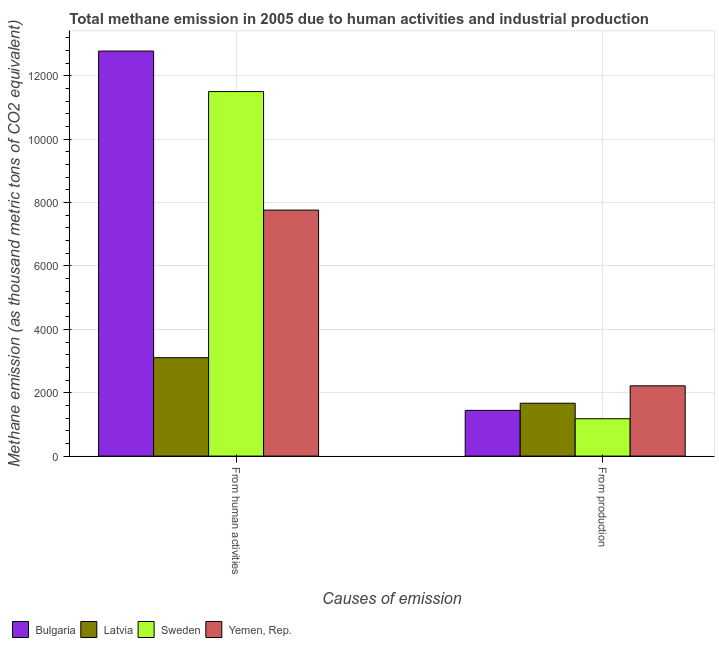How many different coloured bars are there?
Provide a succinct answer. 4. How many groups of bars are there?
Provide a short and direct response. 2. Are the number of bars per tick equal to the number of legend labels?
Provide a short and direct response. Yes. How many bars are there on the 1st tick from the left?
Your answer should be very brief. 4. How many bars are there on the 2nd tick from the right?
Your answer should be very brief. 4. What is the label of the 2nd group of bars from the left?
Keep it short and to the point. From production. What is the amount of emissions from human activities in Yemen, Rep.?
Keep it short and to the point. 7761.1. Across all countries, what is the maximum amount of emissions from human activities?
Provide a short and direct response. 1.28e+04. Across all countries, what is the minimum amount of emissions from human activities?
Provide a succinct answer. 3105. In which country was the amount of emissions generated from industries maximum?
Keep it short and to the point. Yemen, Rep. In which country was the amount of emissions from human activities minimum?
Your response must be concise. Latvia. What is the total amount of emissions from human activities in the graph?
Ensure brevity in your answer.  3.51e+04. What is the difference between the amount of emissions from human activities in Yemen, Rep. and that in Sweden?
Make the answer very short. -3739.8. What is the difference between the amount of emissions generated from industries in Yemen, Rep. and the amount of emissions from human activities in Sweden?
Your answer should be compact. -9284. What is the average amount of emissions generated from industries per country?
Your answer should be compact. 1626.85. What is the difference between the amount of emissions generated from industries and amount of emissions from human activities in Bulgaria?
Keep it short and to the point. -1.13e+04. In how many countries, is the amount of emissions from human activities greater than 9600 thousand metric tons?
Make the answer very short. 2. What is the ratio of the amount of emissions generated from industries in Latvia to that in Sweden?
Your answer should be very brief. 1.41. Is the amount of emissions generated from industries in Sweden less than that in Yemen, Rep.?
Provide a short and direct response. Yes. What does the 3rd bar from the left in From production represents?
Your answer should be very brief. Sweden. What does the 3rd bar from the right in From production represents?
Provide a succinct answer. Latvia. How many bars are there?
Offer a very short reply. 8. Are all the bars in the graph horizontal?
Your response must be concise. No. How many countries are there in the graph?
Make the answer very short. 4. Are the values on the major ticks of Y-axis written in scientific E-notation?
Make the answer very short. No. Does the graph contain any zero values?
Provide a short and direct response. No. Where does the legend appear in the graph?
Provide a short and direct response. Bottom left. What is the title of the graph?
Provide a succinct answer. Total methane emission in 2005 due to human activities and industrial production. Does "Sri Lanka" appear as one of the legend labels in the graph?
Offer a terse response. No. What is the label or title of the X-axis?
Give a very brief answer. Causes of emission. What is the label or title of the Y-axis?
Your response must be concise. Methane emission (as thousand metric tons of CO2 equivalent). What is the Methane emission (as thousand metric tons of CO2 equivalent) in Bulgaria in From human activities?
Provide a succinct answer. 1.28e+04. What is the Methane emission (as thousand metric tons of CO2 equivalent) in Latvia in From human activities?
Keep it short and to the point. 3105. What is the Methane emission (as thousand metric tons of CO2 equivalent) in Sweden in From human activities?
Provide a short and direct response. 1.15e+04. What is the Methane emission (as thousand metric tons of CO2 equivalent) in Yemen, Rep. in From human activities?
Give a very brief answer. 7761.1. What is the Methane emission (as thousand metric tons of CO2 equivalent) in Bulgaria in From production?
Your response must be concise. 1442.8. What is the Methane emission (as thousand metric tons of CO2 equivalent) of Latvia in From production?
Offer a terse response. 1668.3. What is the Methane emission (as thousand metric tons of CO2 equivalent) in Sweden in From production?
Ensure brevity in your answer.  1179.4. What is the Methane emission (as thousand metric tons of CO2 equivalent) of Yemen, Rep. in From production?
Offer a terse response. 2216.9. Across all Causes of emission, what is the maximum Methane emission (as thousand metric tons of CO2 equivalent) in Bulgaria?
Your answer should be compact. 1.28e+04. Across all Causes of emission, what is the maximum Methane emission (as thousand metric tons of CO2 equivalent) of Latvia?
Provide a succinct answer. 3105. Across all Causes of emission, what is the maximum Methane emission (as thousand metric tons of CO2 equivalent) of Sweden?
Offer a very short reply. 1.15e+04. Across all Causes of emission, what is the maximum Methane emission (as thousand metric tons of CO2 equivalent) of Yemen, Rep.?
Your response must be concise. 7761.1. Across all Causes of emission, what is the minimum Methane emission (as thousand metric tons of CO2 equivalent) of Bulgaria?
Make the answer very short. 1442.8. Across all Causes of emission, what is the minimum Methane emission (as thousand metric tons of CO2 equivalent) in Latvia?
Give a very brief answer. 1668.3. Across all Causes of emission, what is the minimum Methane emission (as thousand metric tons of CO2 equivalent) of Sweden?
Your response must be concise. 1179.4. Across all Causes of emission, what is the minimum Methane emission (as thousand metric tons of CO2 equivalent) of Yemen, Rep.?
Your answer should be compact. 2216.9. What is the total Methane emission (as thousand metric tons of CO2 equivalent) of Bulgaria in the graph?
Ensure brevity in your answer.  1.42e+04. What is the total Methane emission (as thousand metric tons of CO2 equivalent) of Latvia in the graph?
Give a very brief answer. 4773.3. What is the total Methane emission (as thousand metric tons of CO2 equivalent) in Sweden in the graph?
Make the answer very short. 1.27e+04. What is the total Methane emission (as thousand metric tons of CO2 equivalent) of Yemen, Rep. in the graph?
Provide a succinct answer. 9978. What is the difference between the Methane emission (as thousand metric tons of CO2 equivalent) in Bulgaria in From human activities and that in From production?
Keep it short and to the point. 1.13e+04. What is the difference between the Methane emission (as thousand metric tons of CO2 equivalent) of Latvia in From human activities and that in From production?
Provide a succinct answer. 1436.7. What is the difference between the Methane emission (as thousand metric tons of CO2 equivalent) of Sweden in From human activities and that in From production?
Provide a succinct answer. 1.03e+04. What is the difference between the Methane emission (as thousand metric tons of CO2 equivalent) in Yemen, Rep. in From human activities and that in From production?
Ensure brevity in your answer.  5544.2. What is the difference between the Methane emission (as thousand metric tons of CO2 equivalent) of Bulgaria in From human activities and the Methane emission (as thousand metric tons of CO2 equivalent) of Latvia in From production?
Offer a very short reply. 1.11e+04. What is the difference between the Methane emission (as thousand metric tons of CO2 equivalent) in Bulgaria in From human activities and the Methane emission (as thousand metric tons of CO2 equivalent) in Sweden in From production?
Your answer should be compact. 1.16e+04. What is the difference between the Methane emission (as thousand metric tons of CO2 equivalent) in Bulgaria in From human activities and the Methane emission (as thousand metric tons of CO2 equivalent) in Yemen, Rep. in From production?
Offer a terse response. 1.06e+04. What is the difference between the Methane emission (as thousand metric tons of CO2 equivalent) in Latvia in From human activities and the Methane emission (as thousand metric tons of CO2 equivalent) in Sweden in From production?
Your answer should be very brief. 1925.6. What is the difference between the Methane emission (as thousand metric tons of CO2 equivalent) of Latvia in From human activities and the Methane emission (as thousand metric tons of CO2 equivalent) of Yemen, Rep. in From production?
Provide a short and direct response. 888.1. What is the difference between the Methane emission (as thousand metric tons of CO2 equivalent) of Sweden in From human activities and the Methane emission (as thousand metric tons of CO2 equivalent) of Yemen, Rep. in From production?
Provide a short and direct response. 9284. What is the average Methane emission (as thousand metric tons of CO2 equivalent) in Bulgaria per Causes of emission?
Offer a very short reply. 7110.6. What is the average Methane emission (as thousand metric tons of CO2 equivalent) of Latvia per Causes of emission?
Offer a very short reply. 2386.65. What is the average Methane emission (as thousand metric tons of CO2 equivalent) in Sweden per Causes of emission?
Give a very brief answer. 6340.15. What is the average Methane emission (as thousand metric tons of CO2 equivalent) of Yemen, Rep. per Causes of emission?
Your response must be concise. 4989. What is the difference between the Methane emission (as thousand metric tons of CO2 equivalent) of Bulgaria and Methane emission (as thousand metric tons of CO2 equivalent) of Latvia in From human activities?
Ensure brevity in your answer.  9673.4. What is the difference between the Methane emission (as thousand metric tons of CO2 equivalent) of Bulgaria and Methane emission (as thousand metric tons of CO2 equivalent) of Sweden in From human activities?
Provide a short and direct response. 1277.5. What is the difference between the Methane emission (as thousand metric tons of CO2 equivalent) in Bulgaria and Methane emission (as thousand metric tons of CO2 equivalent) in Yemen, Rep. in From human activities?
Your response must be concise. 5017.3. What is the difference between the Methane emission (as thousand metric tons of CO2 equivalent) of Latvia and Methane emission (as thousand metric tons of CO2 equivalent) of Sweden in From human activities?
Give a very brief answer. -8395.9. What is the difference between the Methane emission (as thousand metric tons of CO2 equivalent) in Latvia and Methane emission (as thousand metric tons of CO2 equivalent) in Yemen, Rep. in From human activities?
Your answer should be very brief. -4656.1. What is the difference between the Methane emission (as thousand metric tons of CO2 equivalent) of Sweden and Methane emission (as thousand metric tons of CO2 equivalent) of Yemen, Rep. in From human activities?
Offer a very short reply. 3739.8. What is the difference between the Methane emission (as thousand metric tons of CO2 equivalent) in Bulgaria and Methane emission (as thousand metric tons of CO2 equivalent) in Latvia in From production?
Keep it short and to the point. -225.5. What is the difference between the Methane emission (as thousand metric tons of CO2 equivalent) of Bulgaria and Methane emission (as thousand metric tons of CO2 equivalent) of Sweden in From production?
Make the answer very short. 263.4. What is the difference between the Methane emission (as thousand metric tons of CO2 equivalent) of Bulgaria and Methane emission (as thousand metric tons of CO2 equivalent) of Yemen, Rep. in From production?
Offer a terse response. -774.1. What is the difference between the Methane emission (as thousand metric tons of CO2 equivalent) of Latvia and Methane emission (as thousand metric tons of CO2 equivalent) of Sweden in From production?
Your answer should be very brief. 488.9. What is the difference between the Methane emission (as thousand metric tons of CO2 equivalent) in Latvia and Methane emission (as thousand metric tons of CO2 equivalent) in Yemen, Rep. in From production?
Make the answer very short. -548.6. What is the difference between the Methane emission (as thousand metric tons of CO2 equivalent) of Sweden and Methane emission (as thousand metric tons of CO2 equivalent) of Yemen, Rep. in From production?
Give a very brief answer. -1037.5. What is the ratio of the Methane emission (as thousand metric tons of CO2 equivalent) in Bulgaria in From human activities to that in From production?
Your answer should be very brief. 8.86. What is the ratio of the Methane emission (as thousand metric tons of CO2 equivalent) in Latvia in From human activities to that in From production?
Your response must be concise. 1.86. What is the ratio of the Methane emission (as thousand metric tons of CO2 equivalent) of Sweden in From human activities to that in From production?
Make the answer very short. 9.75. What is the ratio of the Methane emission (as thousand metric tons of CO2 equivalent) of Yemen, Rep. in From human activities to that in From production?
Your answer should be very brief. 3.5. What is the difference between the highest and the second highest Methane emission (as thousand metric tons of CO2 equivalent) in Bulgaria?
Make the answer very short. 1.13e+04. What is the difference between the highest and the second highest Methane emission (as thousand metric tons of CO2 equivalent) of Latvia?
Offer a terse response. 1436.7. What is the difference between the highest and the second highest Methane emission (as thousand metric tons of CO2 equivalent) in Sweden?
Offer a very short reply. 1.03e+04. What is the difference between the highest and the second highest Methane emission (as thousand metric tons of CO2 equivalent) in Yemen, Rep.?
Provide a succinct answer. 5544.2. What is the difference between the highest and the lowest Methane emission (as thousand metric tons of CO2 equivalent) in Bulgaria?
Offer a terse response. 1.13e+04. What is the difference between the highest and the lowest Methane emission (as thousand metric tons of CO2 equivalent) in Latvia?
Keep it short and to the point. 1436.7. What is the difference between the highest and the lowest Methane emission (as thousand metric tons of CO2 equivalent) of Sweden?
Ensure brevity in your answer.  1.03e+04. What is the difference between the highest and the lowest Methane emission (as thousand metric tons of CO2 equivalent) of Yemen, Rep.?
Give a very brief answer. 5544.2. 